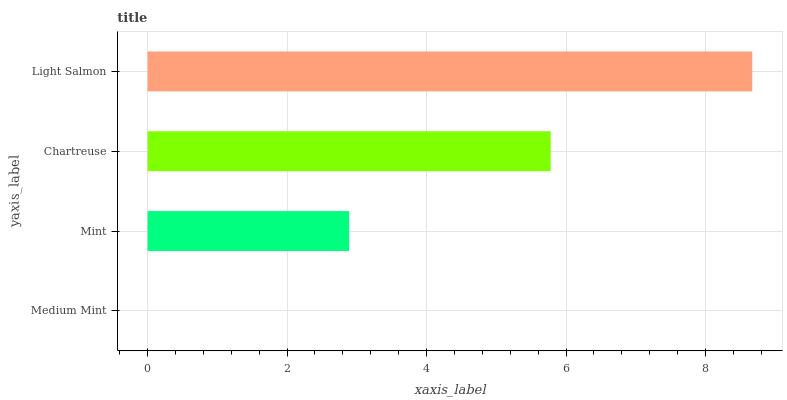Is Medium Mint the minimum?
Answer yes or no. Yes. Is Light Salmon the maximum?
Answer yes or no. Yes. Is Mint the minimum?
Answer yes or no. No. Is Mint the maximum?
Answer yes or no. No. Is Mint greater than Medium Mint?
Answer yes or no. Yes. Is Medium Mint less than Mint?
Answer yes or no. Yes. Is Medium Mint greater than Mint?
Answer yes or no. No. Is Mint less than Medium Mint?
Answer yes or no. No. Is Chartreuse the high median?
Answer yes or no. Yes. Is Mint the low median?
Answer yes or no. Yes. Is Light Salmon the high median?
Answer yes or no. No. Is Light Salmon the low median?
Answer yes or no. No. 